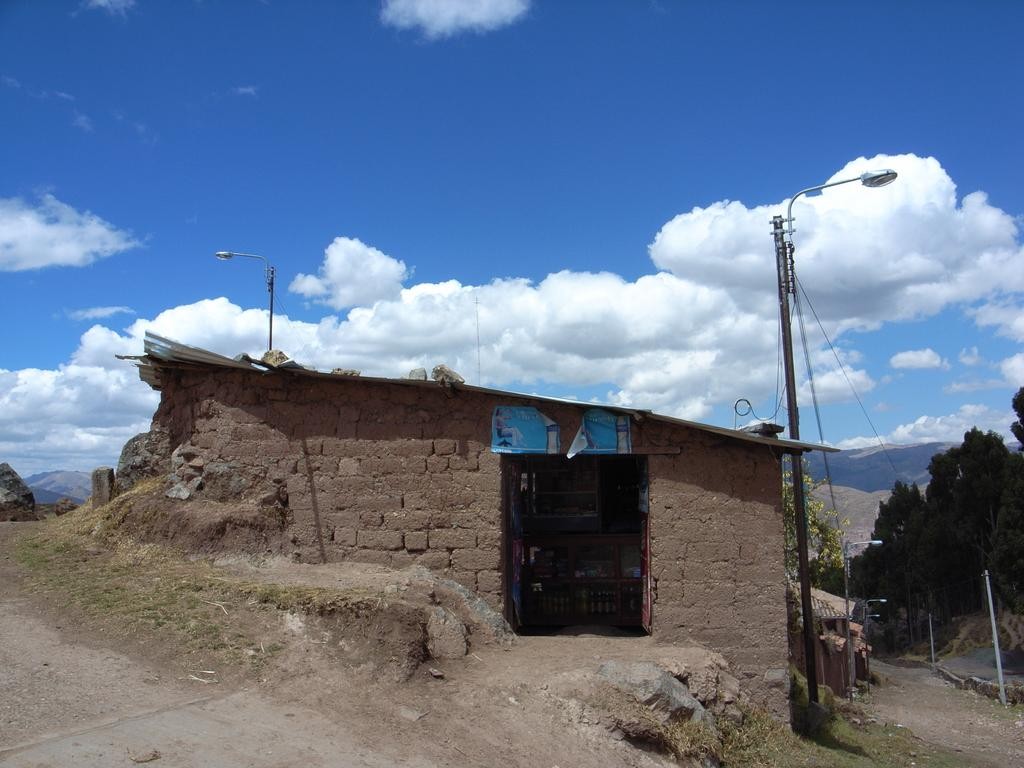What type of structure is in the image? There is a house in the image. What can be seen on the right side of the house? There are poles with cables and lights on the right side of the house. What type of vegetation is visible behind the house? There are trees visible behind the house. What is visible in the background of the image? The sky is visible in the image. What type of brick is used to build the playground board in the image? There is no playground or board present in the image; it features a house with poles, cables, lights, trees, and the sky. 